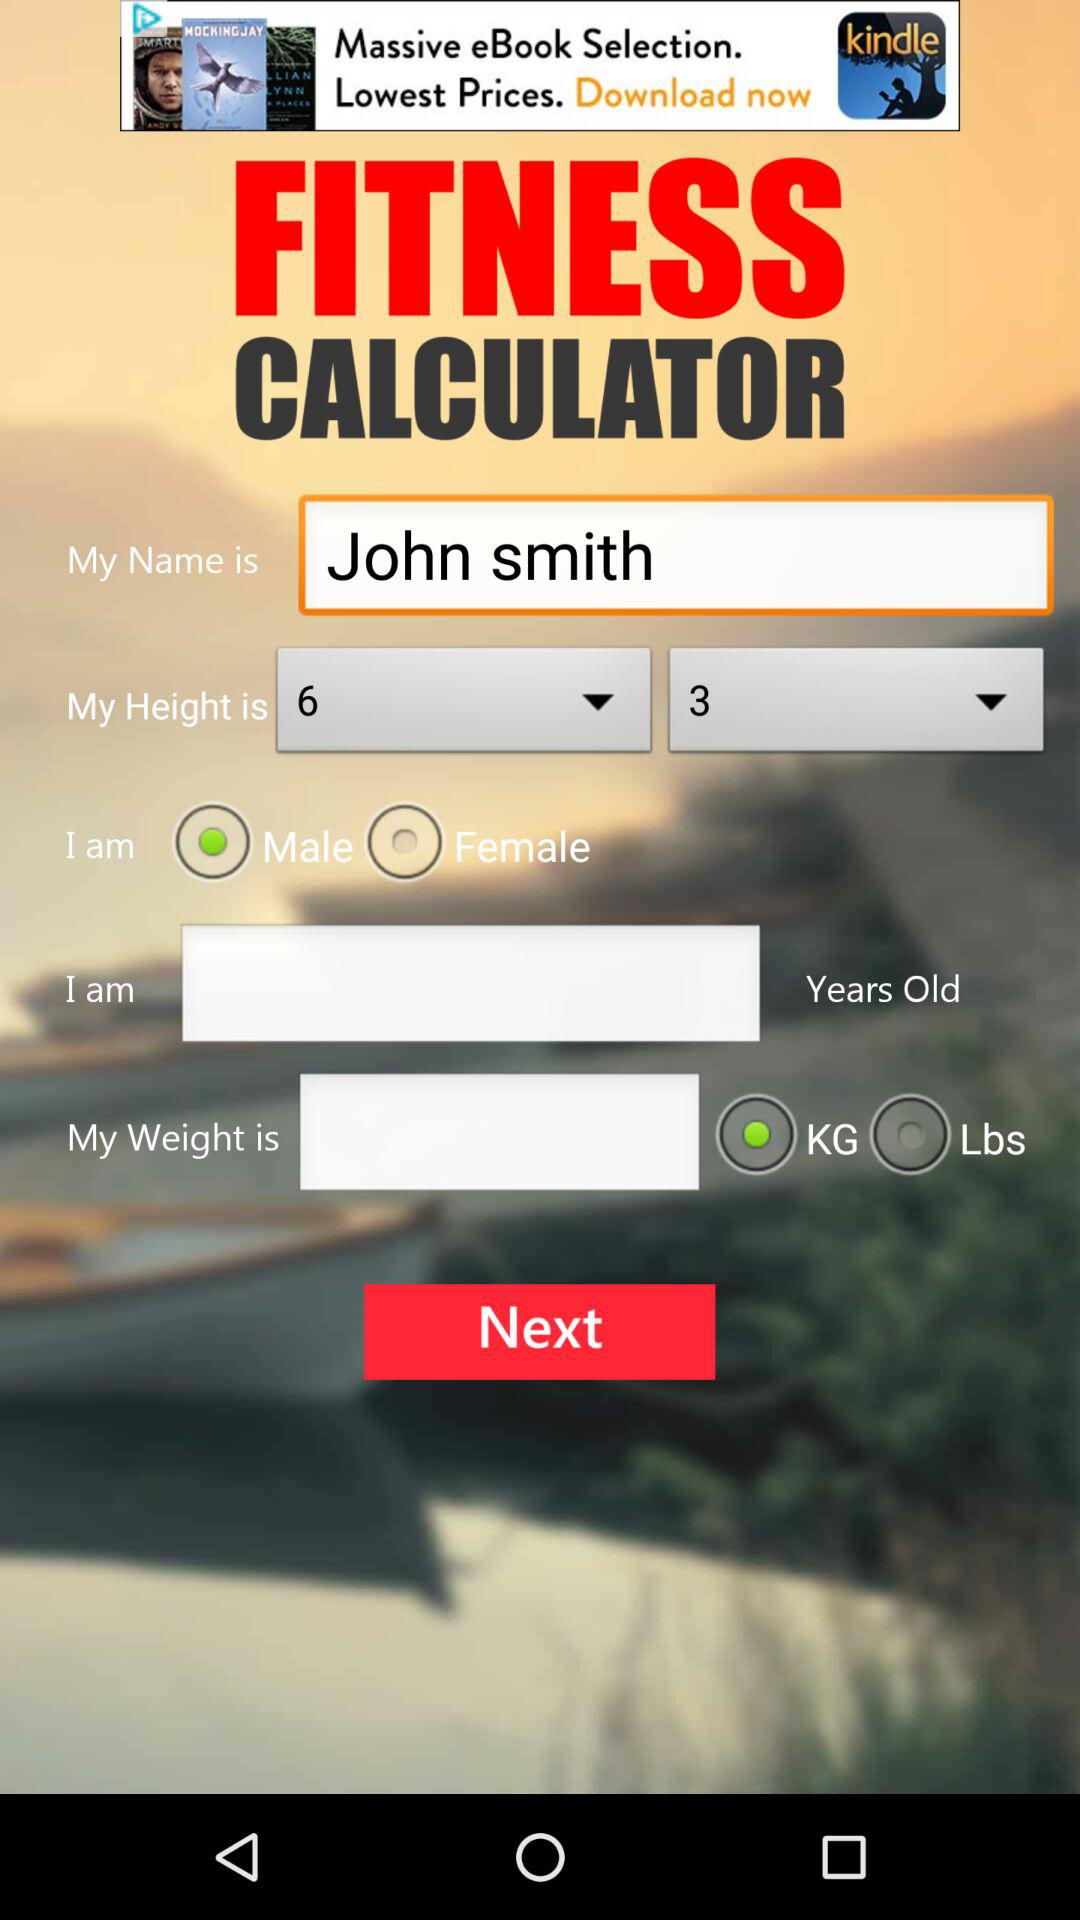What is the height? The height is 6 feet 3 inches. 